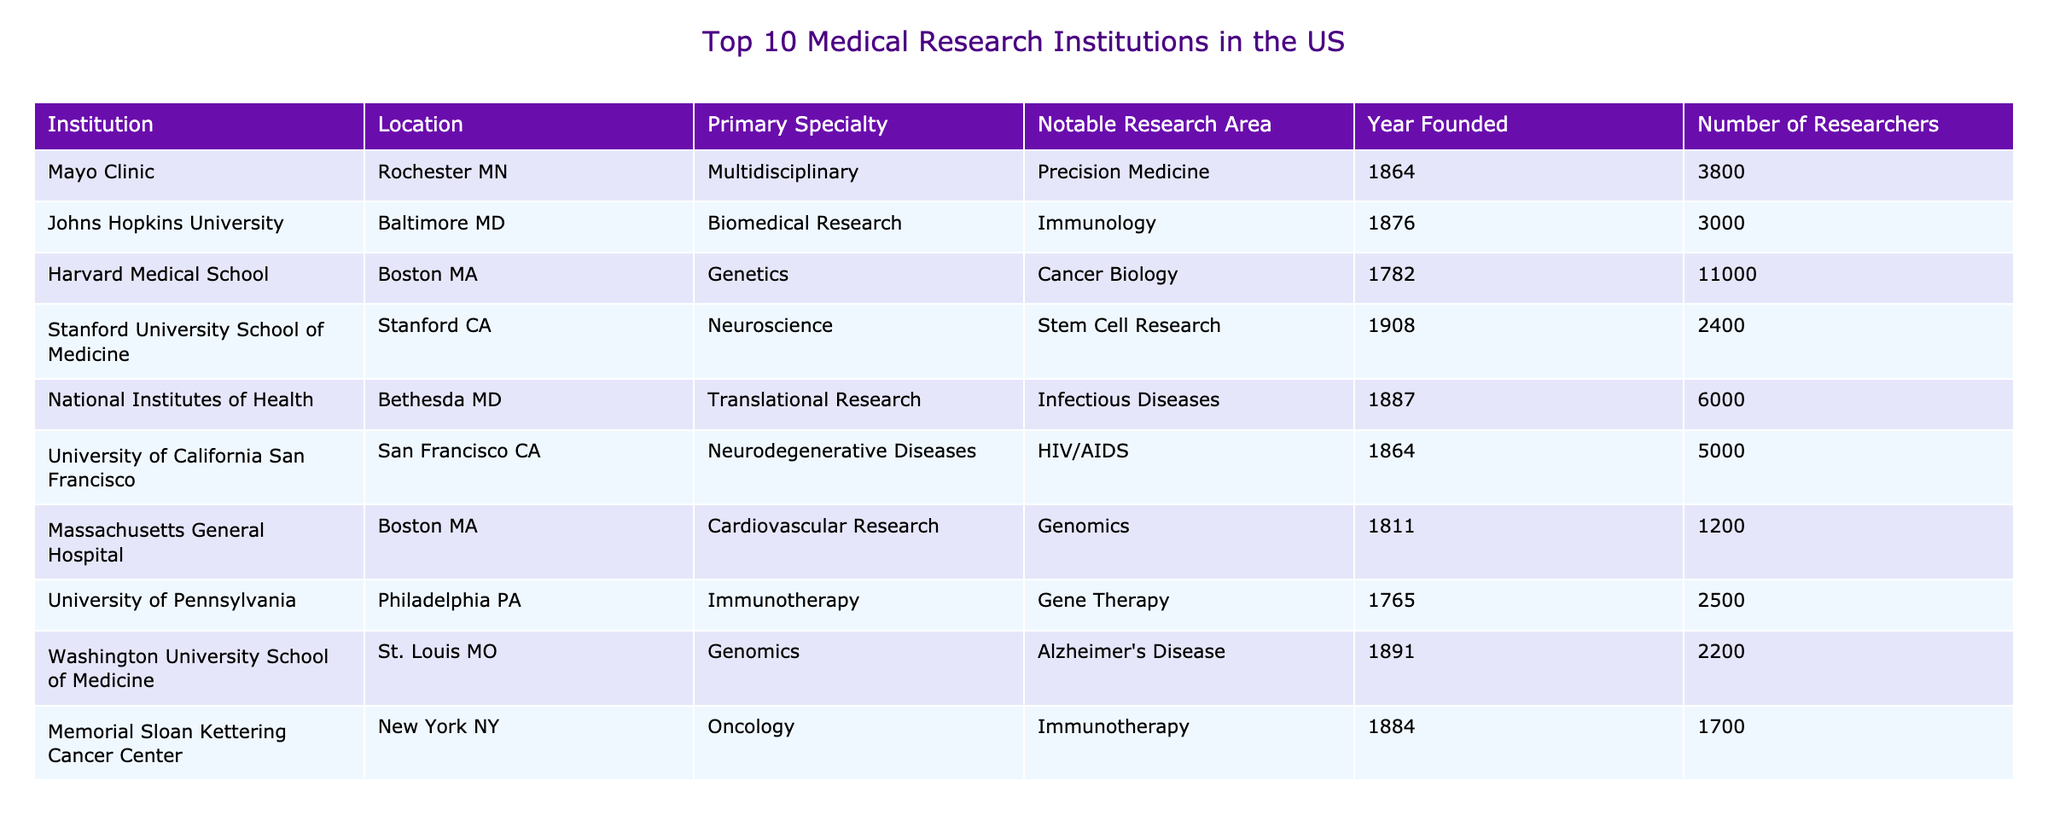What is the primary specialty of Harvard Medical School? Harvard Medical School specializes in Genetics, as indicated in the table under the "Primary Specialty" column.
Answer: Genetics Which institution has the highest number of researchers? The table shows Harvard Medical School with 11,000 researchers, which is the highest among all listed institutions.
Answer: Harvard Medical School True or False: Johns Hopkins University is located in New York. The table specifies that Johns Hopkins University is located in Baltimore, MD, not New York, making the statement false.
Answer: False What are the notable research areas for the National Institutes of Health? According to the table, the notable research area for the National Institutes of Health is Infectious Diseases.
Answer: Infectious Diseases Calculate the total number of researchers across the top 10 institutions. Adding the number of researchers from all institutions: 3800 + 3000 + 11000 + 2400 + 6000 + 5000 + 1200 + 2500 + 2200 + 1700 = 40500 gives the total.
Answer: 40500 Which institution focuses on oncology? Memorial Sloan Kettering Cancer Center is noted in the table as specializing in oncology, according to the "Primary Specialty" column.
Answer: Memorial Sloan Kettering Cancer Center How many institutions specialize in immunotherapy? The table lists two institutions that specialize in immunotherapy: Johns Hopkins University and the University of Pennsylvania, counted from the "Primary Specialty" column.
Answer: 2 What year was the Mayo Clinic founded? The table indicates that the Mayo Clinic was founded in 1864, which is directly stated under the "Year Founded" column.
Answer: 1864 Is the University of California San Francisco involved in cardiovascular research? The table shows that the University of California San Francisco specializes in Neurodegenerative Diseases, not cardiovascular research, so the answer is no.
Answer: No 